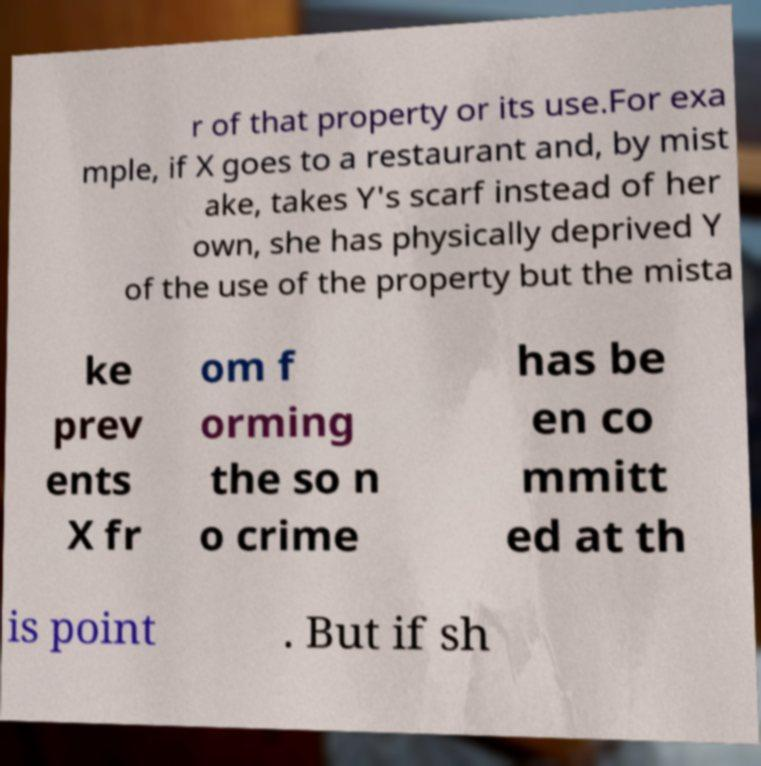There's text embedded in this image that I need extracted. Can you transcribe it verbatim? r of that property or its use.For exa mple, if X goes to a restaurant and, by mist ake, takes Y's scarf instead of her own, she has physically deprived Y of the use of the property but the mista ke prev ents X fr om f orming the so n o crime has be en co mmitt ed at th is point . But if sh 